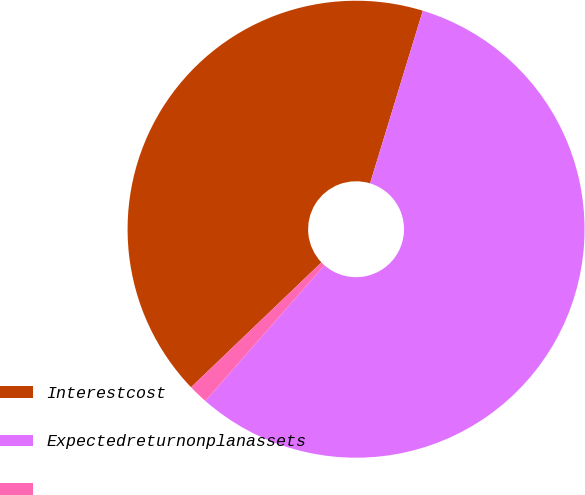<chart> <loc_0><loc_0><loc_500><loc_500><pie_chart><fcel>Interestcost<fcel>Expectedreturnonplanassets<fcel>Unnamed: 2<nl><fcel>41.88%<fcel>56.75%<fcel>1.38%<nl></chart> 